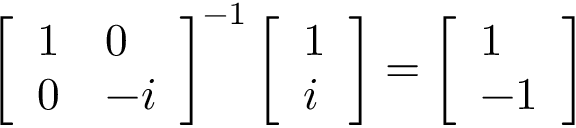<formula> <loc_0><loc_0><loc_500><loc_500>\left [ \begin{array} { l l } { 1 } & { 0 } \\ { 0 } & { - i } \end{array} \right ] ^ { - 1 } \left [ \begin{array} { l } { 1 } \\ { i } \end{array} \right ] = \left [ \begin{array} { l } { 1 } \\ { - 1 } \end{array} \right ]</formula> 